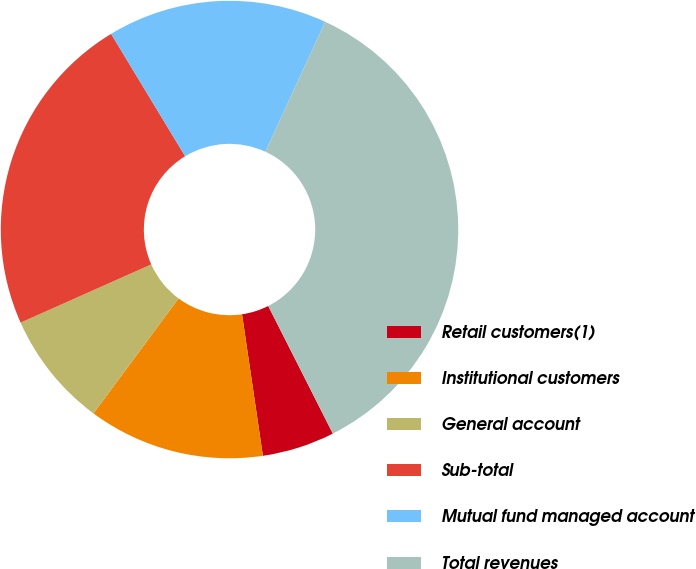<chart> <loc_0><loc_0><loc_500><loc_500><pie_chart><fcel>Retail customers(1)<fcel>Institutional customers<fcel>General account<fcel>Sub-total<fcel>Mutual fund managed account<fcel>Total revenues<nl><fcel>5.13%<fcel>12.47%<fcel>8.19%<fcel>23.01%<fcel>15.53%<fcel>35.67%<nl></chart> 